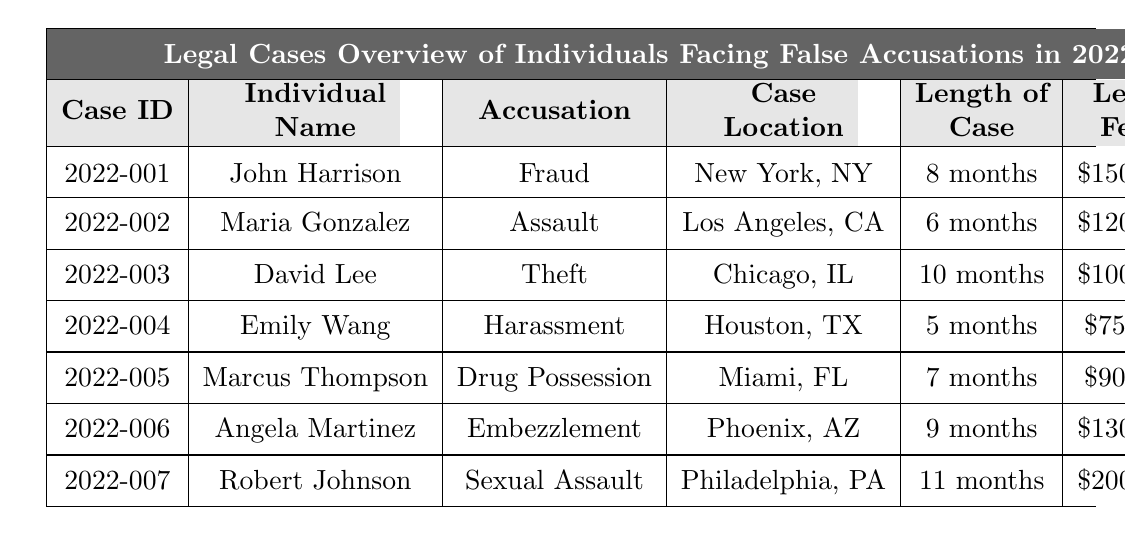What is the total amount of legal fees for all the individuals? The legal fees for each individual are $150,000, $120,000, $100,000, $75,000, $90,000, $130,000, and $200,000. Adding them together gives a total of $150,000 + $120,000 + $100,000 + $75,000 + $90,000 + $130,000 + $200,000 = $965,000.
Answer: $965,000 Which individual had the longest case duration? Looking at the length of each case, Robert Johnson's case lasted 11 months, which is longer than any other individual listed.
Answer: Robert Johnson How many individuals faced accusations related to theft or fraud? There are 2 individuals: John Harrison (Fraud) and David Lee (Theft).
Answer: 2 Is there anyone who faced false accusations for drug-related charges? The table lists Marcus Thompson as facing an accusation of Drug Possession, suggesting a drug-related charge.
Answer: Yes What is the median length of the cases? The lengths of the cases are 8, 6, 10, 5, 7, 9, and 11 months. When arranged in order, they are: 5, 6, 7, 8, 9, 10, 11. The median (middle value) is 8 months.
Answer: 8 months Which two locations had the least legal fees? The legal fees in Houston, TX (Emily Wang) are $75,000 and in Miami, FL (Marcus Thompson) are $90,000. When comparing these values, the least are the ones in Houston and Miami.
Answer: Houston, TX and Miami, FL How many months did John Harrison's case last, and what was the verdict? John Harrison's case lasted 8 months and the verdict was "Not Guilty".
Answer: 8 months, Not Guilty Which accusation did individuals spend the most on legal fees? Robert Johnson spent $200,000 on legal fees for the accusation of Sexual Assault. This is the highest amount listed.
Answer: Sexual Assault If all individuals were found "Not Guilty," what percentage of the accused is not guilty? There are 7 individuals listed, and all are found "Not Guilty." Therefore, the percentage is (7/7)*100 = 100%.
Answer: 100% What was the average legal fee incurred by each individual? The total legal fees sum to $965,000 for 7 individuals, so the average is $965,000 / 7 ≈ $137,857.14.
Answer: Approximately $137,857.14 